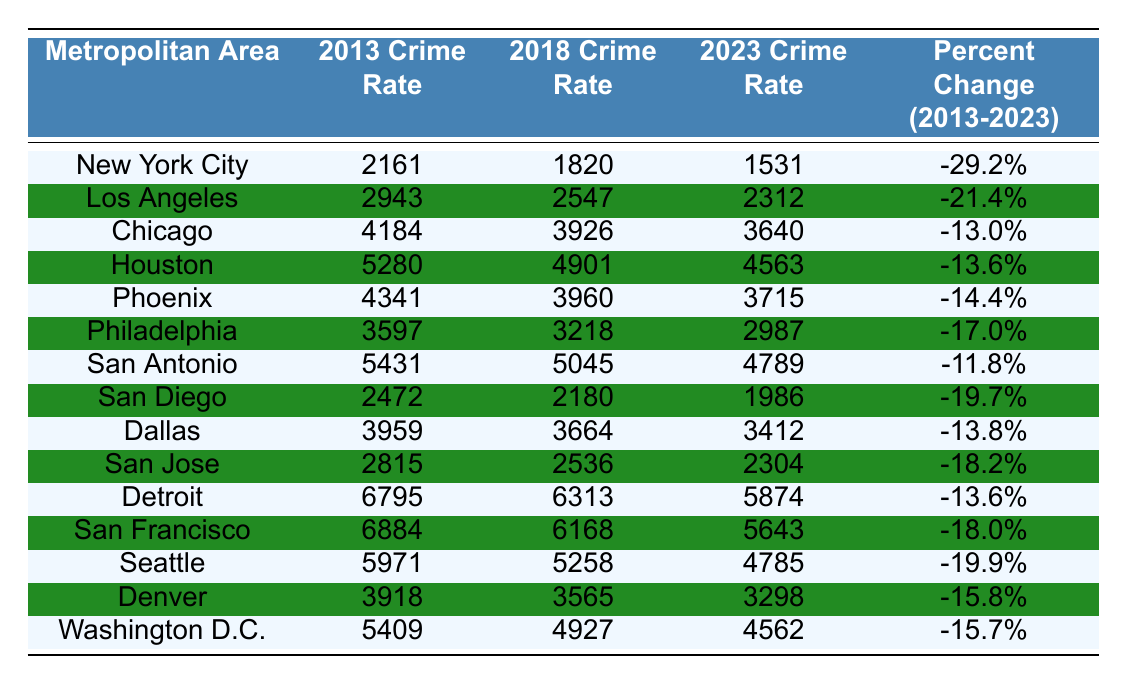What was the crime rate in Chicago in 2023? The table directly shows that the crime rate in Chicago for 2023 is listed as 3640.
Answer: 3640 Which city had the highest crime rate in 2013? A quick glance at the 2013 Crime Rate column reveals that Detroit had the highest crime rate at 6795.
Answer: Detroit What was the percent change in crime rates for San Diego from 2013 to 2023? The table shows a percent change of -19.7% for San Diego from 2013 to 2023.
Answer: -19.7% Which metropolitan area experienced a crime rate decrease of over 20% from 2013 to 2023? By examining the Percent Change column, Los Angeles at -21.4% and New York City at -29.2% both experienced decreases over 20%.
Answer: Los Angeles, New York City What is the average crime rate in 2018 across these metropolitan areas? To find the average, sum the 2018 crime rates (1820 + 2547 + 3926 + 4901 + 3960 + 3218 + 5045 + 2180 + 3664 + 2536 + 6313 + 6168 + 5258 + 3565 + 4927) = 50328 and divide by 15 cities: 50328 / 15 = 3355.2.
Answer: 3355.2 Has the crime rate in San Antonio decreased from 2013 to 2023? The table indicates that the crime rate in San Antonio was 5431 in 2013 and 4789 in 2023, showing a decrease.
Answer: Yes Which city had the lowest crime rate in 2023? By looking at the 2023 Crime Rate column, San Diego shows the lowest crime rate at 1986.
Answer: San Diego If we compare the percent changes, which city experienced the least reduction in crime rates from 2013 to 2023? San Antonio has the least reduction with -11.8%. This is determined by looking at each city's percent change and identifying the highest value.
Answer: San Antonio Which city's 2023 crime rate was closest to the 2018 crime rate of Chicago? The 2018 crime rate for Chicago is 3926, and the closest 2023 crime rate is Philadelphia at 2987, calculated by comparing with other values.
Answer: Philadelphia How many metropolitan areas have a crime rate in 2023 above 5000? By checking the 2023 Crime Rate column, the only areas above 5000 are Houston (4563), Detroit (5874), and Washington D.C. (4562), which totals 3.
Answer: 3 What was the crime rate in Philadelphia in 2013? The table specifies that the crime rate in Philadelphia for 2013 was 3597.
Answer: 3597 